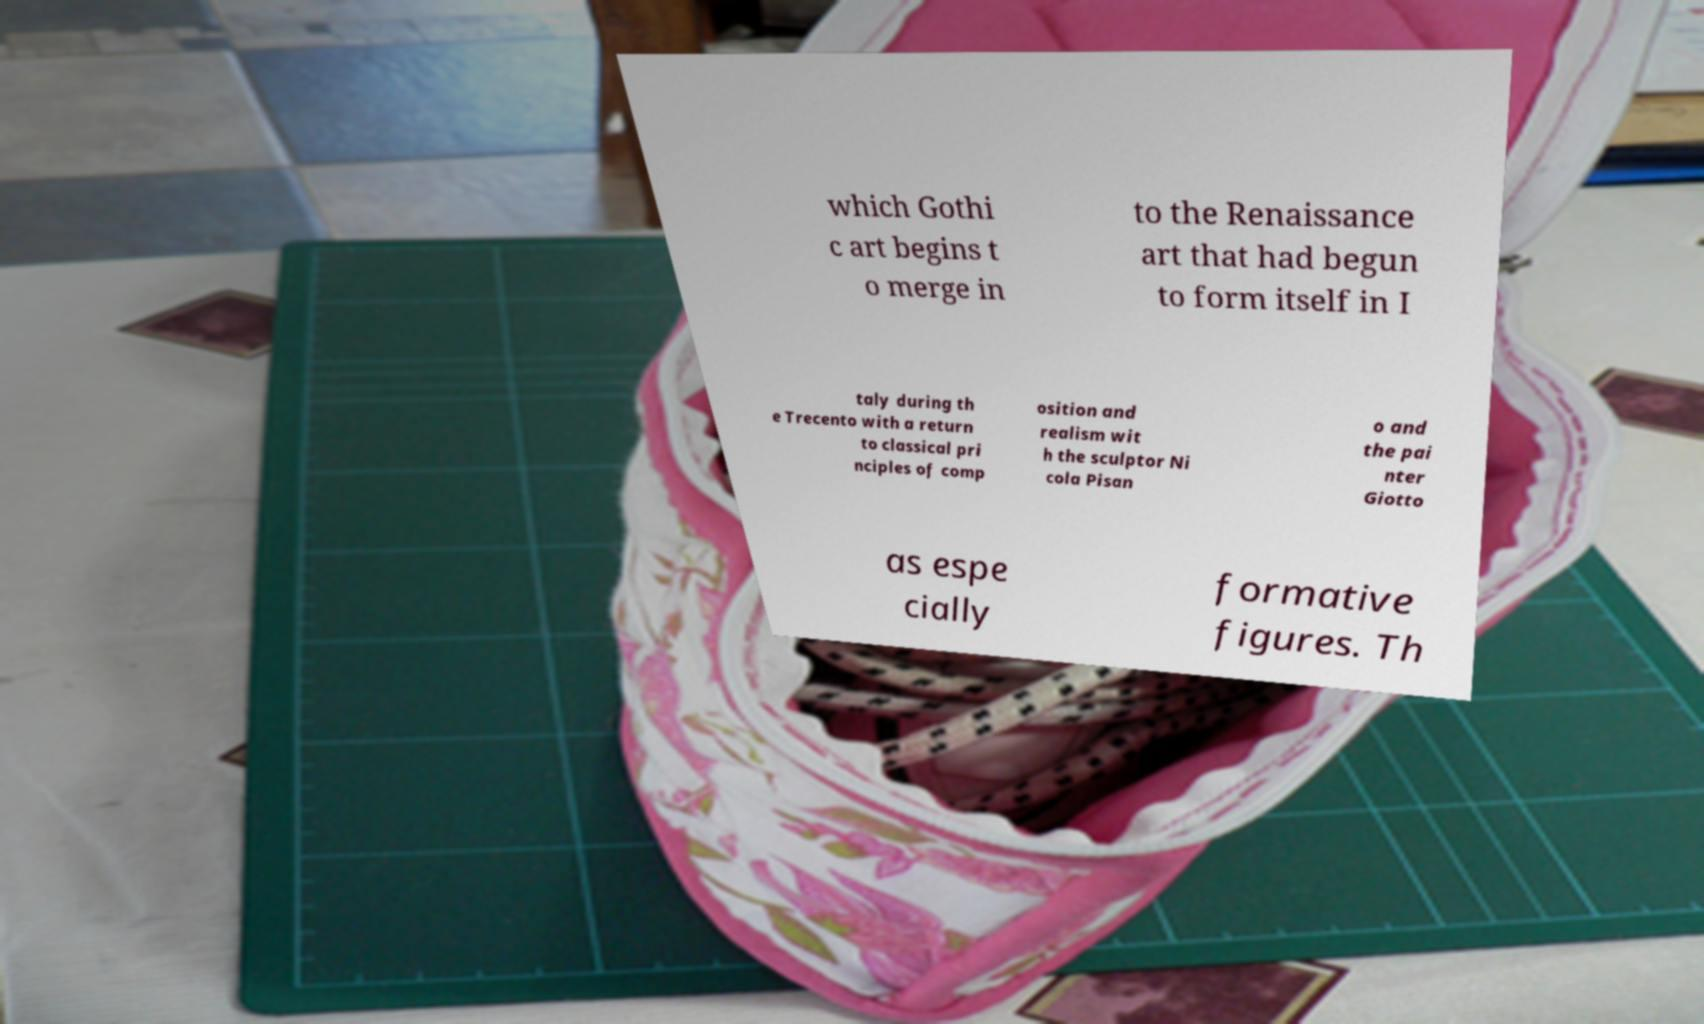Please read and relay the text visible in this image. What does it say? which Gothi c art begins t o merge in to the Renaissance art that had begun to form itself in I taly during th e Trecento with a return to classical pri nciples of comp osition and realism wit h the sculptor Ni cola Pisan o and the pai nter Giotto as espe cially formative figures. Th 